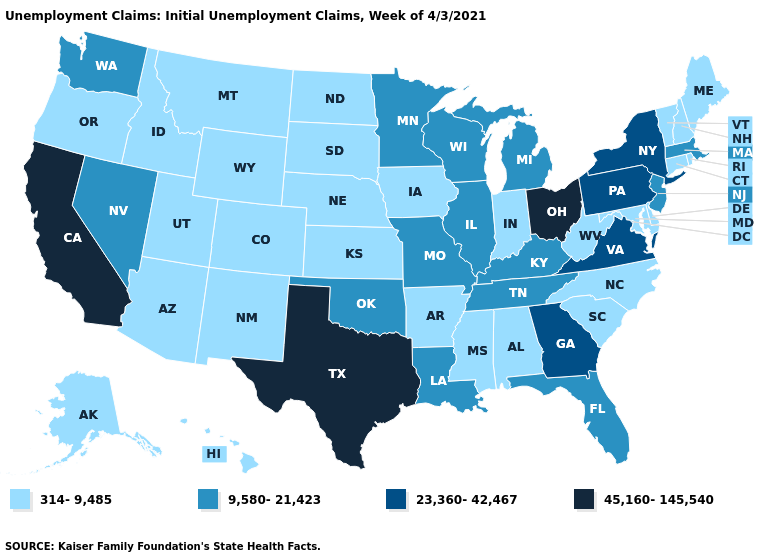What is the value of South Carolina?
Concise answer only. 314-9,485. What is the lowest value in states that border Montana?
Concise answer only. 314-9,485. Name the states that have a value in the range 9,580-21,423?
Short answer required. Florida, Illinois, Kentucky, Louisiana, Massachusetts, Michigan, Minnesota, Missouri, Nevada, New Jersey, Oklahoma, Tennessee, Washington, Wisconsin. What is the value of Maryland?
Give a very brief answer. 314-9,485. Does Washington have the highest value in the USA?
Be succinct. No. Among the states that border Illinois , does Kentucky have the lowest value?
Quick response, please. No. What is the value of Indiana?
Answer briefly. 314-9,485. Name the states that have a value in the range 23,360-42,467?
Keep it brief. Georgia, New York, Pennsylvania, Virginia. What is the highest value in the USA?
Keep it brief. 45,160-145,540. What is the value of Virginia?
Short answer required. 23,360-42,467. Does Ohio have the highest value in the USA?
Quick response, please. Yes. What is the value of Alabama?
Concise answer only. 314-9,485. Name the states that have a value in the range 45,160-145,540?
Be succinct. California, Ohio, Texas. Does Colorado have a lower value than Delaware?
Write a very short answer. No. 